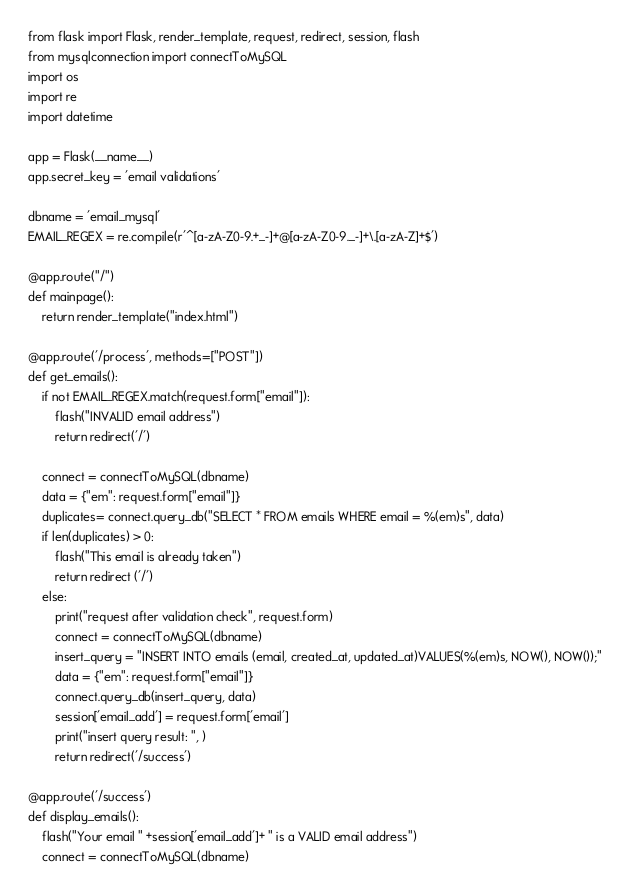<code> <loc_0><loc_0><loc_500><loc_500><_Python_>from flask import Flask, render_template, request, redirect, session, flash
from mysqlconnection import connectToMySQL
import os
import re
import datetime

app = Flask(__name__)
app.secret_key = 'email validations'

dbname = 'email_mysql'
EMAIL_REGEX = re.compile(r'^[a-zA-Z0-9.+_-]+@[a-zA-Z0-9._-]+\.[a-zA-Z]+$') 

@app.route("/")
def mainpage():
    return render_template("index.html")

@app.route('/process', methods=["POST"])
def get_emails():
    if not EMAIL_REGEX.match(request.form["email"]):
        flash("INVALID email address")
        return redirect('/')
    
    connect = connectToMySQL(dbname)
    data = {"em": request.form["email"]}
    duplicates= connect.query_db("SELECT * FROM emails WHERE email = %(em)s", data)
    if len(duplicates) > 0:
        flash("This email is already taken")
        return redirect ('/')
    else:
        print("request after validation check", request.form)
        connect = connectToMySQL(dbname)
        insert_query = "INSERT INTO emails (email, created_at, updated_at)VALUES(%(em)s, NOW(), NOW());"
        data = {"em": request.form["email"]}
        connect.query_db(insert_query, data)
        session['email_add'] = request.form['email']
        print("insert query result: ", )
        return redirect('/success')

@app.route('/success')
def display_emails():
    flash("Your email " +session['email_add']+ " is a VALID email address")
    connect = connectToMySQL(dbname)</code> 